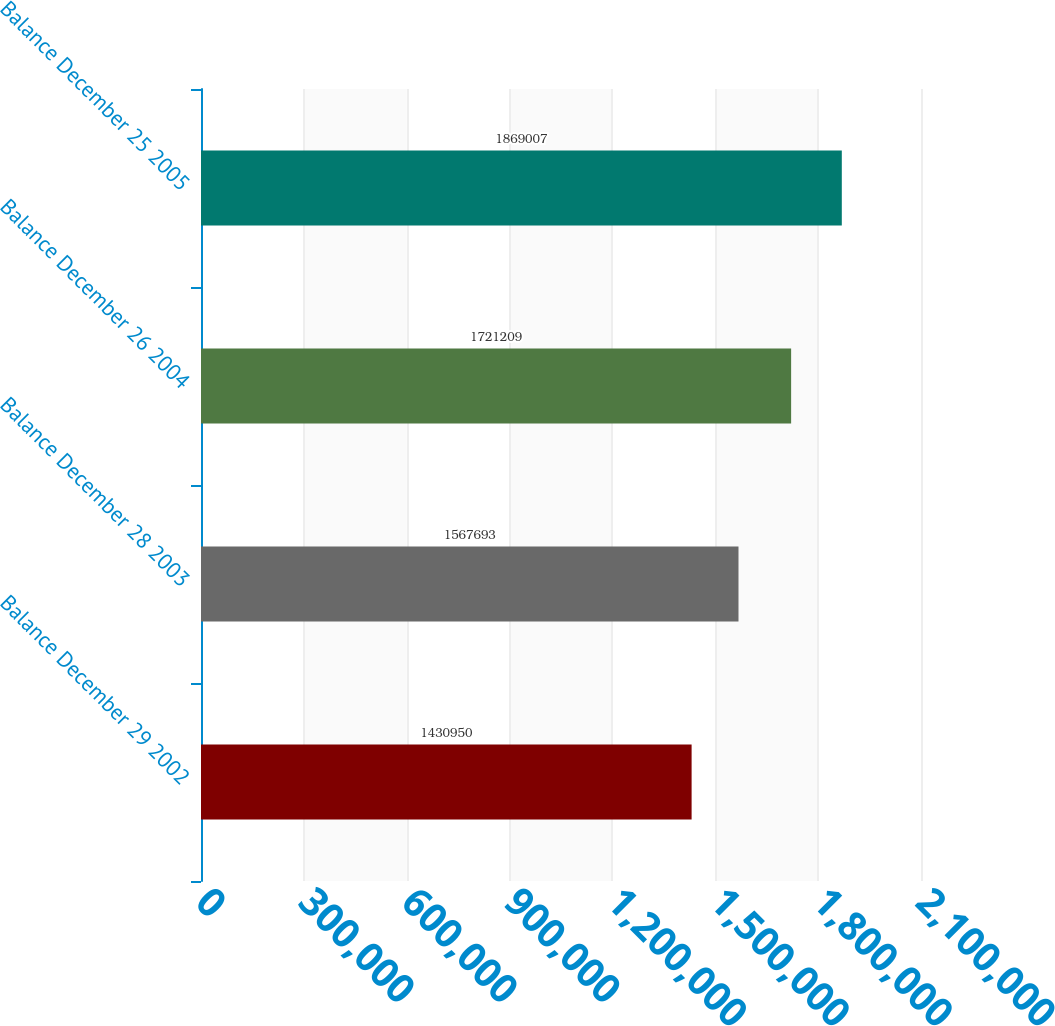Convert chart to OTSL. <chart><loc_0><loc_0><loc_500><loc_500><bar_chart><fcel>Balance December 29 2002<fcel>Balance December 28 2003<fcel>Balance December 26 2004<fcel>Balance December 25 2005<nl><fcel>1.43095e+06<fcel>1.56769e+06<fcel>1.72121e+06<fcel>1.86901e+06<nl></chart> 